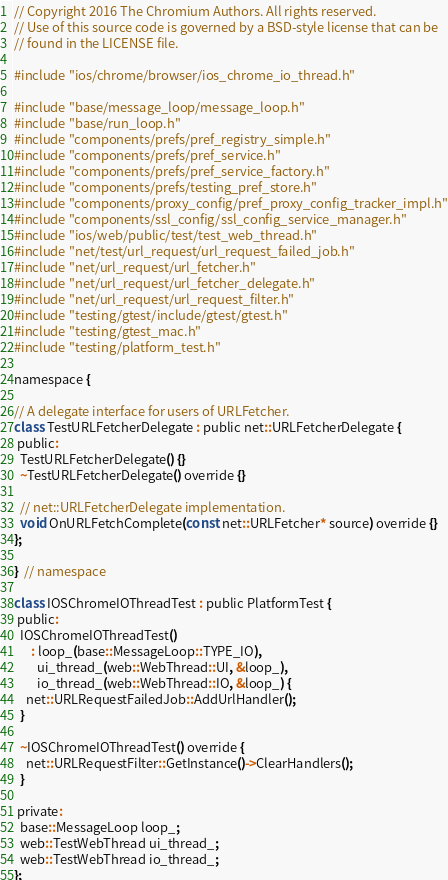<code> <loc_0><loc_0><loc_500><loc_500><_ObjectiveC_>// Copyright 2016 The Chromium Authors. All rights reserved.
// Use of this source code is governed by a BSD-style license that can be
// found in the LICENSE file.

#include "ios/chrome/browser/ios_chrome_io_thread.h"

#include "base/message_loop/message_loop.h"
#include "base/run_loop.h"
#include "components/prefs/pref_registry_simple.h"
#include "components/prefs/pref_service.h"
#include "components/prefs/pref_service_factory.h"
#include "components/prefs/testing_pref_store.h"
#include "components/proxy_config/pref_proxy_config_tracker_impl.h"
#include "components/ssl_config/ssl_config_service_manager.h"
#include "ios/web/public/test/test_web_thread.h"
#include "net/test/url_request/url_request_failed_job.h"
#include "net/url_request/url_fetcher.h"
#include "net/url_request/url_fetcher_delegate.h"
#include "net/url_request/url_request_filter.h"
#include "testing/gtest/include/gtest/gtest.h"
#include "testing/gtest_mac.h"
#include "testing/platform_test.h"

namespace {

// A delegate interface for users of URLFetcher.
class TestURLFetcherDelegate : public net::URLFetcherDelegate {
 public:
  TestURLFetcherDelegate() {}
  ~TestURLFetcherDelegate() override {}

  // net::URLFetcherDelegate implementation.
  void OnURLFetchComplete(const net::URLFetcher* source) override {}
};

}  // namespace

class IOSChromeIOThreadTest : public PlatformTest {
 public:
  IOSChromeIOThreadTest()
      : loop_(base::MessageLoop::TYPE_IO),
        ui_thread_(web::WebThread::UI, &loop_),
        io_thread_(web::WebThread::IO, &loop_) {
    net::URLRequestFailedJob::AddUrlHandler();
  }

  ~IOSChromeIOThreadTest() override {
    net::URLRequestFilter::GetInstance()->ClearHandlers();
  }

 private:
  base::MessageLoop loop_;
  web::TestWebThread ui_thread_;
  web::TestWebThread io_thread_;
};
</code> 